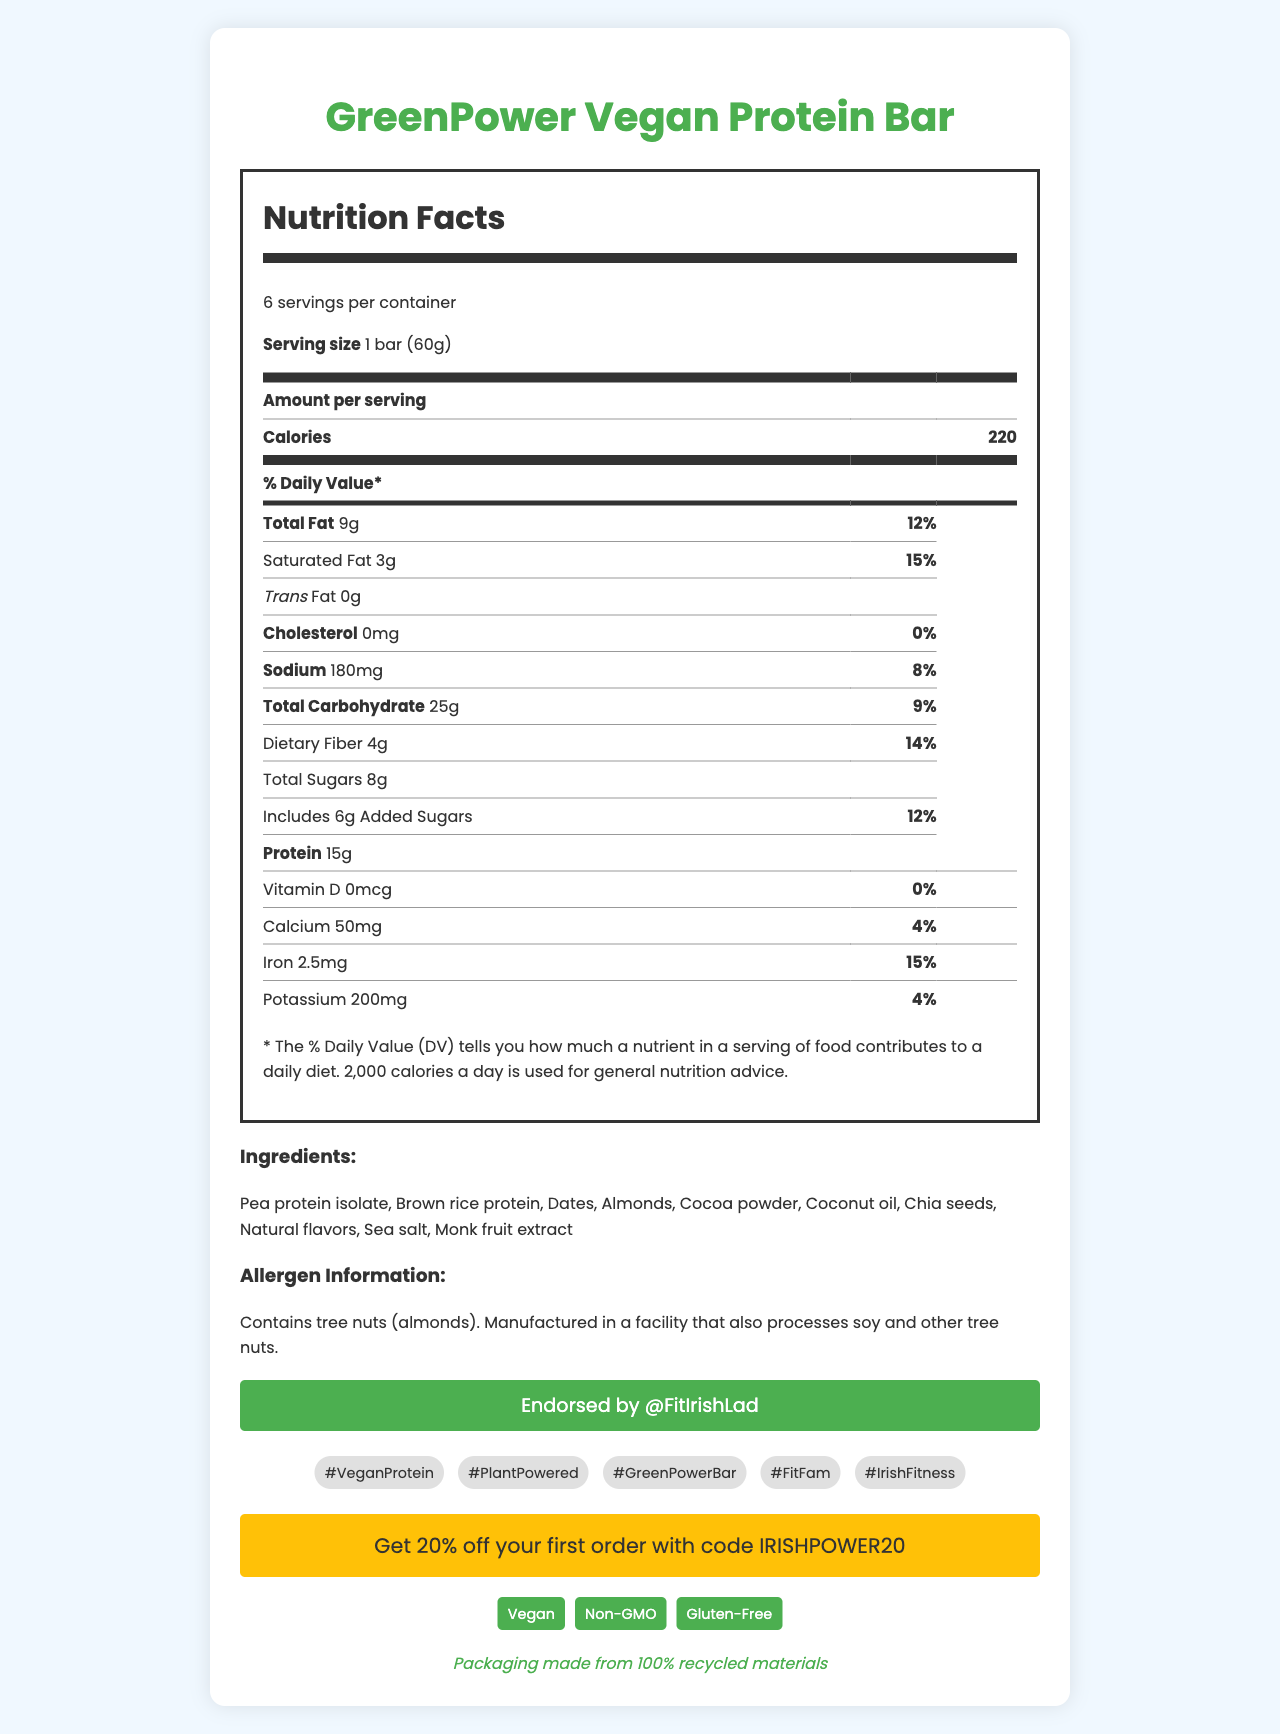what is the serving size for GreenPower Vegan Protein Bar? The serving size is listed as "1 bar (60g)" in the nutrition facts section of the document.
Answer: 1 bar (60g) how many servings are there per container? The document states that there are "6 servings per container."
Answer: 6 how many calories are in one serving of the GreenPower Vegan Protein Bar? The calorie content per serving is shown as 220 in the nutrition facts section.
Answer: 220 what vitamin is not present in the GreenPower Vegan Protein Bar? The document lists Vitamin D as "0mcg" with a daily value of 0%.
Answer: Vitamin D what is the main source of protein in the ingredients list? Pea protein isolate is the first ingredient listed, indicating it is the primary source of protein.
Answer: Pea protein isolate how much total fat is in one serving of the GreenPower Vegan Protein Bar? A. 5g B. 9g C. 12g D. 15g The total fat per serving is listed as "9g" in the nutrition facts label.
Answer: B. 9g which social media hashtags are promoted along with the product? A. #VeganProtein B. #PlantPowered C. #GreenPowerBar D. #FitFam E. All of the above The document lists several hashtags, including #VeganProtein, #PlantPowered, #GreenPowerBar, and #FitFam.
Answer: E. All of the above is the GreenPower Vegan Protein Bar gluten-free? The document includes a certification section stating the bar is "Gluten-Free."
Answer: Yes describe the allergen information provided for the GreenPower Vegan Protein Bar. The document's allergen information section specifies these details.
Answer: The product contains tree nuts (almonds) and is manufactured in a facility that also processes soy and other tree nuts. who endorses the GreenPower Vegan Protein Bar on Instagram? The endorsement is mentioned in the document as "@FitIrishLad."
Answer: @FitIrishLad what is the daily value percentage of saturated fat in one serving of the GreenPower Vegan Protein Bar? The nutrition facts label shows a daily value of 15% for saturated fat.
Answer: 15% how much dietary fiber is in one bar of this protein bar? The document lists dietary fiber content as "4g."
Answer: 4g can you determine the exact launch date of this protein bar from the document? The document does not provide any details about the launch date.
Answer: Not enough information what discount code can you use to get 20% off your first order on Instagram? The promotion section mentions the code "IRISHPOWER20" for a 20% discount.
Answer: IRISHPOWER20 what percentage of the daily value of iron does one bar provide? The daily value for iron is listed as 15% in the nutrition facts.
Answer: 15% summarize the main details of the GreenPower Vegan Protein Bar as presented in the document. The summary compiles key details regarding nutrition, endorsements, certifications, and promotional elements.
Answer: The GreenPower Vegan Protein Bar is a trendy, plant-based protein bar endorsed by @FitIrishLad. Each serving contains 220 calories, 15g of protein, and various vitamins and minerals, with ingredients like pea protein isolate and chia seeds. It’s certified vegan, non-GMO, and gluten-free, and is promoted with hashtags like #VeganProtein and #FitFam. The packaging is made from 100% recycled materials. how many grams of added sugars are in one serving of the bar? The document lists added sugars as "6g" per serving.
Answer: 6g what are the natural flavors listed in the ingredients? The document does not specify which natural flavors are used, only that there are "natural flavors."
Answer: Cannot be determined 